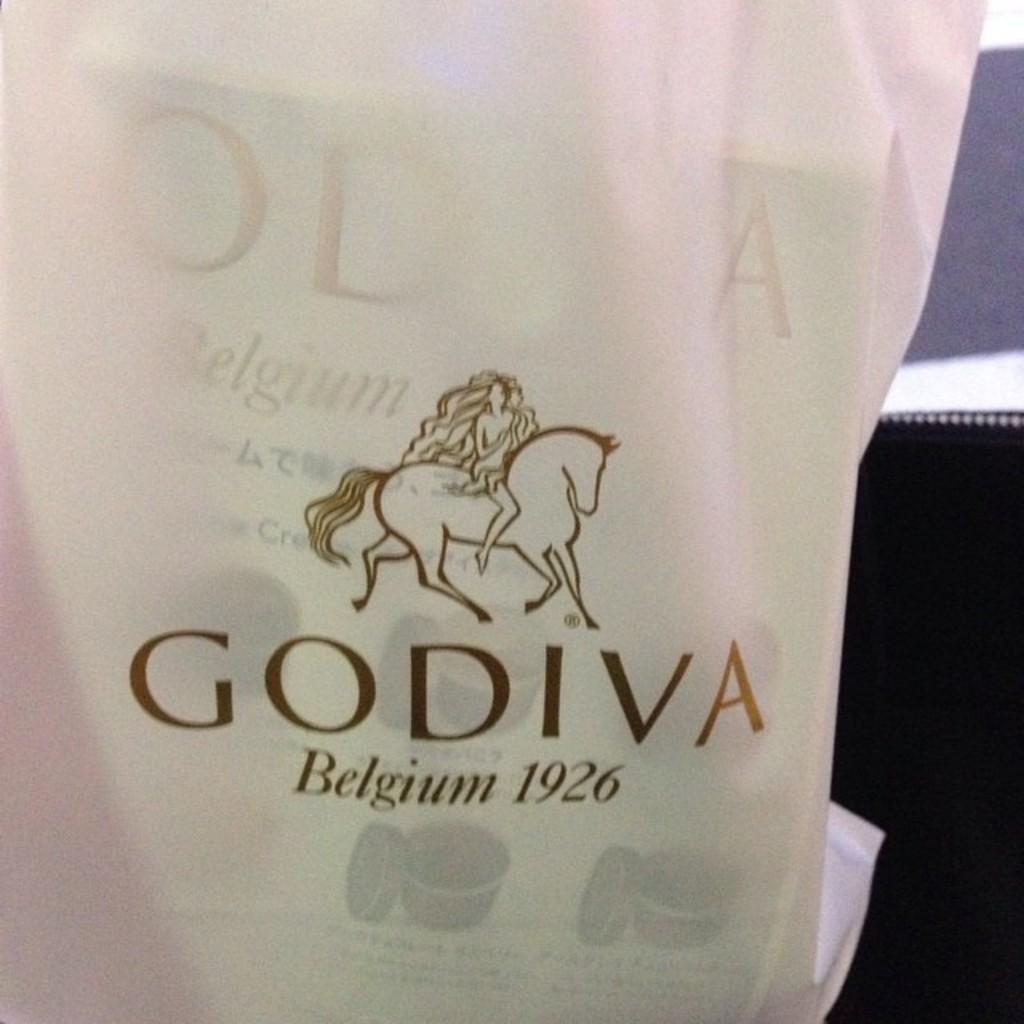What object is visible in the image that might be used for carrying items? There is a bag in the image that might be used for carrying items. What is inside the bag in the image? There is a book inside the bag in the image. What can be seen on the bag in the image? The bag has text and a symbol of a horse on it. Where is the playground located in the image? There is no playground present in the image. What type of animal can be seen interacting with the book in the image? There are no animals present in the image, and the book is not interacting with any animals. 